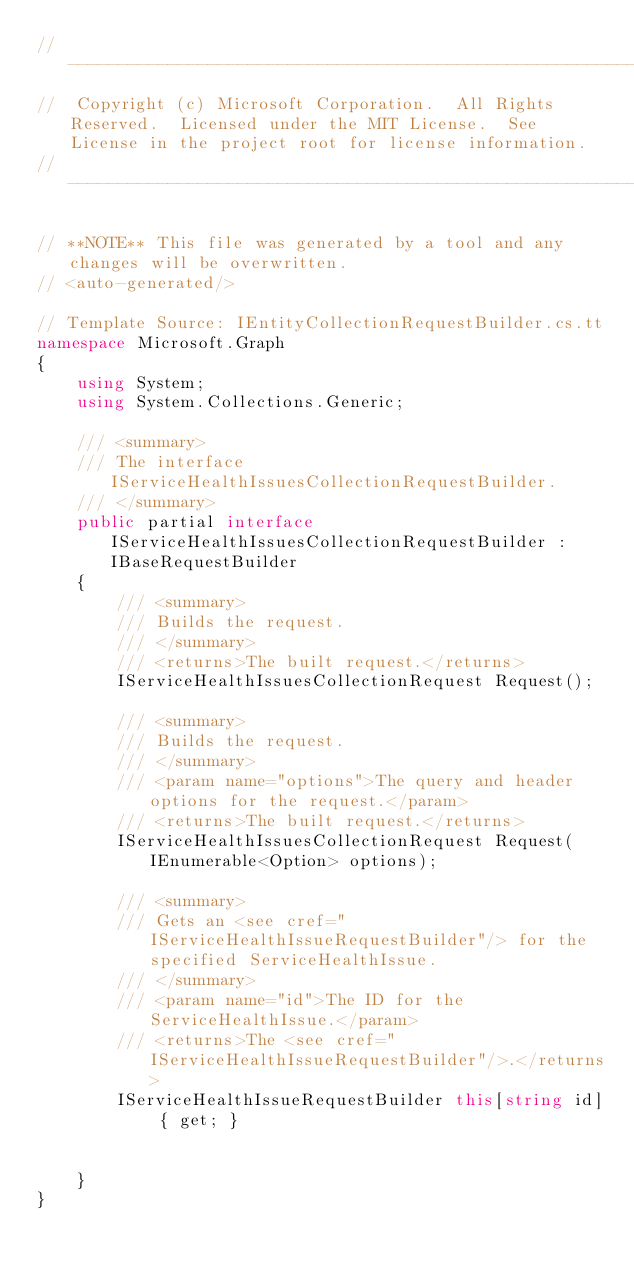<code> <loc_0><loc_0><loc_500><loc_500><_C#_>// ------------------------------------------------------------------------------
//  Copyright (c) Microsoft Corporation.  All Rights Reserved.  Licensed under the MIT License.  See License in the project root for license information.
// ------------------------------------------------------------------------------

// **NOTE** This file was generated by a tool and any changes will be overwritten.
// <auto-generated/>

// Template Source: IEntityCollectionRequestBuilder.cs.tt
namespace Microsoft.Graph
{
    using System;
    using System.Collections.Generic;

    /// <summary>
    /// The interface IServiceHealthIssuesCollectionRequestBuilder.
    /// </summary>
    public partial interface IServiceHealthIssuesCollectionRequestBuilder : IBaseRequestBuilder
    {
        /// <summary>
        /// Builds the request.
        /// </summary>
        /// <returns>The built request.</returns>
        IServiceHealthIssuesCollectionRequest Request();

        /// <summary>
        /// Builds the request.
        /// </summary>
        /// <param name="options">The query and header options for the request.</param>
        /// <returns>The built request.</returns>
        IServiceHealthIssuesCollectionRequest Request(IEnumerable<Option> options);

        /// <summary>
        /// Gets an <see cref="IServiceHealthIssueRequestBuilder"/> for the specified ServiceHealthIssue.
        /// </summary>
        /// <param name="id">The ID for the ServiceHealthIssue.</param>
        /// <returns>The <see cref="IServiceHealthIssueRequestBuilder"/>.</returns>
        IServiceHealthIssueRequestBuilder this[string id] { get; }

        
    }
}
</code> 